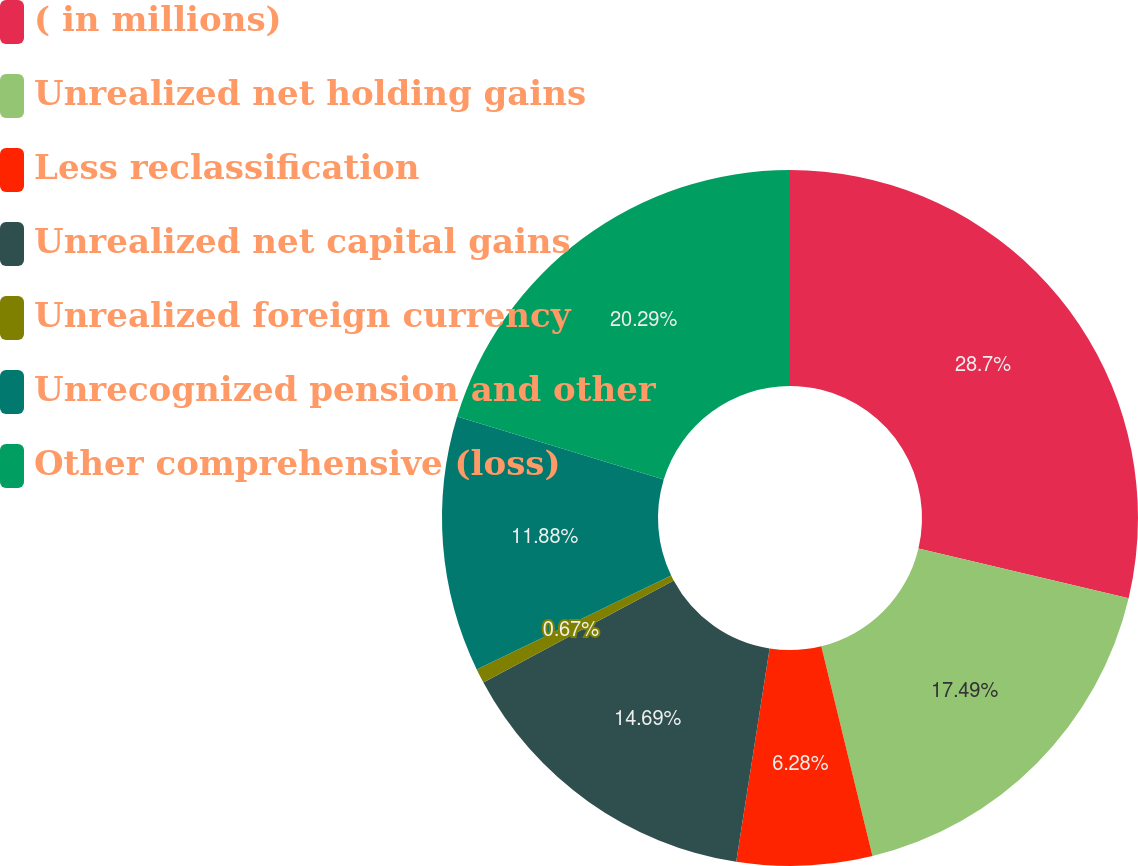Convert chart. <chart><loc_0><loc_0><loc_500><loc_500><pie_chart><fcel>( in millions)<fcel>Unrealized net holding gains<fcel>Less reclassification<fcel>Unrealized net capital gains<fcel>Unrealized foreign currency<fcel>Unrecognized pension and other<fcel>Other comprehensive (loss)<nl><fcel>28.7%<fcel>17.49%<fcel>6.28%<fcel>14.69%<fcel>0.67%<fcel>11.88%<fcel>20.29%<nl></chart> 